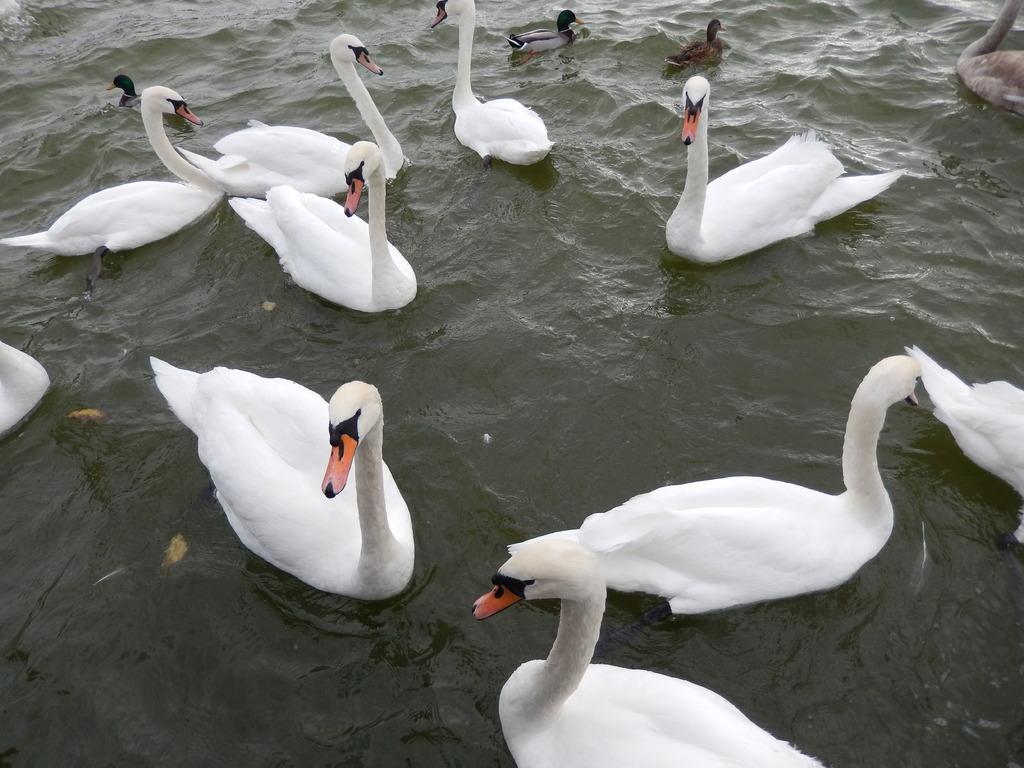Please provide a concise description of this image. In this image we can see many birds in the water. There is a water in the image. 